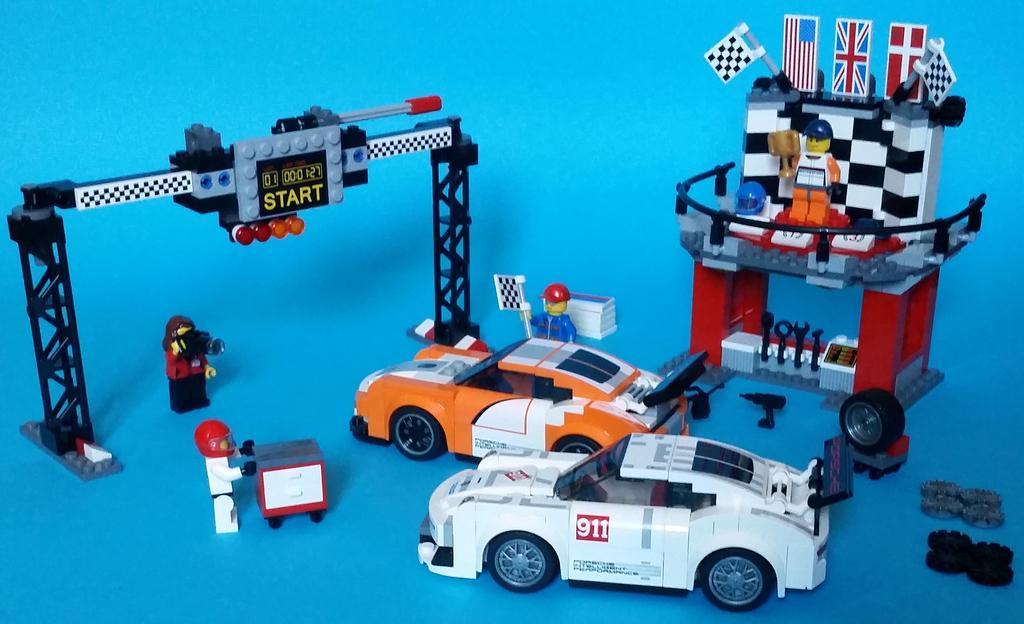In one or two sentences, can you explain what this image depicts? In this picture we can see lego cars, people, trusses, lights, flags, a helmet and some objects on the surface. 